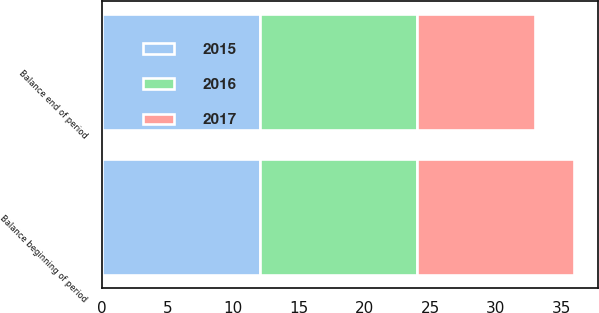Convert chart to OTSL. <chart><loc_0><loc_0><loc_500><loc_500><stacked_bar_chart><ecel><fcel>Balance beginning of period<fcel>Balance end of period<nl><fcel>2017<fcel>12<fcel>9<nl><fcel>2016<fcel>12<fcel>12<nl><fcel>2015<fcel>12<fcel>12<nl></chart> 